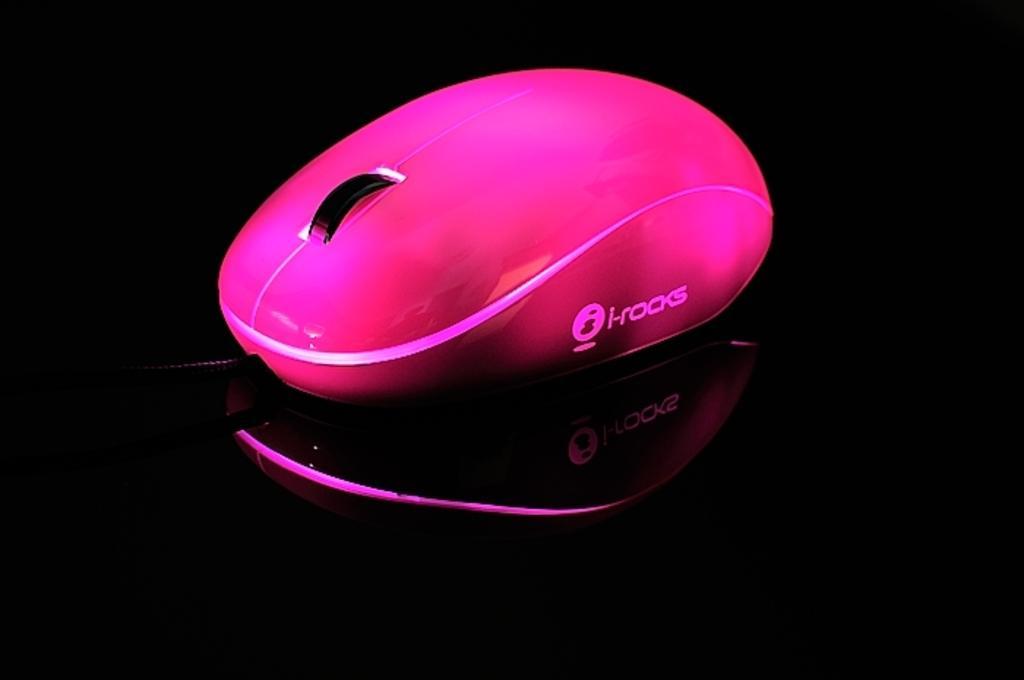In one or two sentences, can you explain what this image depicts? In this picture we can see a pink color mouse with a scroll and a logo on it and this mouse is placed on a black color platform. 